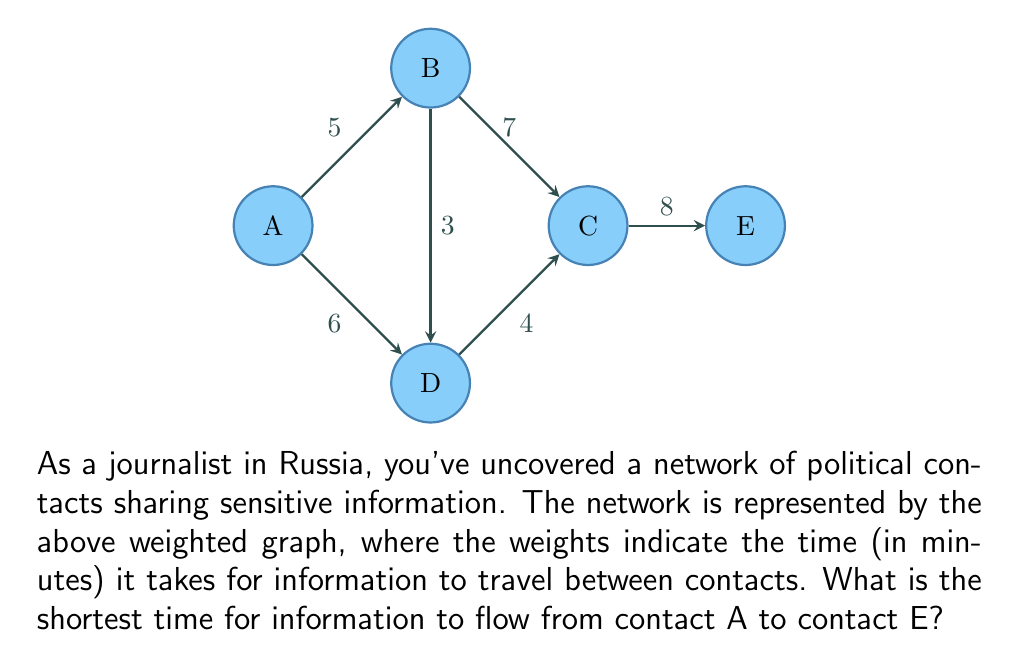Give your solution to this math problem. To solve this problem, we'll use Dijkstra's algorithm to find the shortest path from A to E.

Step 1: Initialize distances
- $d(A) = 0$ (starting node)
- $d(B) = d(C) = d(D) = d(E) = \infty$ (unknown distances to other nodes)

Step 2: Visit node A
- Update $d(B) = 5$
- Update $d(D) = 6$

Step 3: Visit node B (closest unvisited node)
- Update $d(C) = \min(d(C), d(B) + 7) = \min(\infty, 5 + 7) = 12$
- Update $d(D) = \min(d(D), d(B) + 3) = \min(6, 5 + 3) = 6$

Step 4: Visit node D (closest unvisited node)
- Update $d(C) = \min(d(C), d(D) + 4) = \min(12, 6 + 4) = 10$

Step 5: Visit node C (closest unvisited node)
- Update $d(E) = \min(d(E), d(C) + 8) = \min(\infty, 10 + 8) = 18$

Step 6: Visit node E (final node)

The shortest path is A → D → C → E with a total time of 18 minutes.
Answer: 18 minutes 